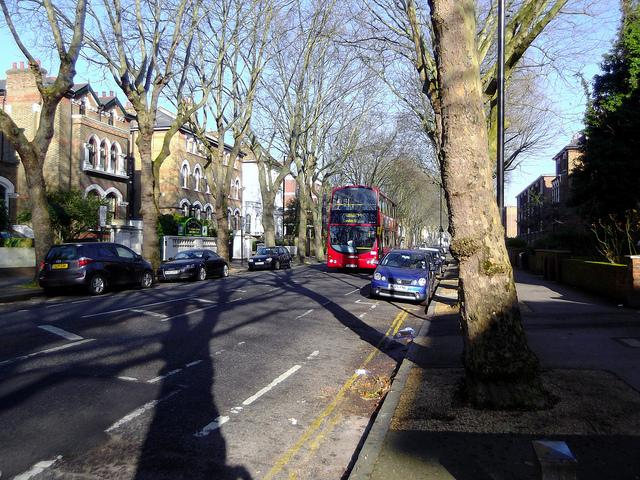Why are the cars lined up along the curb? parked 